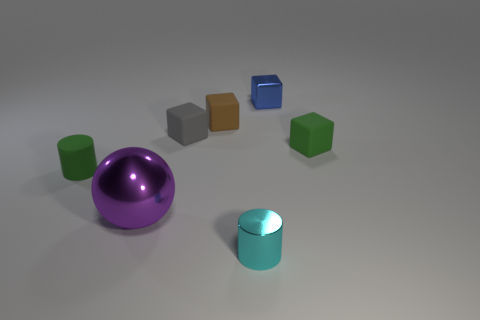There is a matte cube left of the tiny brown rubber thing on the right side of the matte cylinder; what color is it?
Give a very brief answer. Gray. How many small shiny objects are in front of the green rubber block and behind the small brown object?
Provide a short and direct response. 0. Are there more big red matte cylinders than tiny green matte blocks?
Make the answer very short. No. What material is the big purple thing?
Your answer should be very brief. Metal. There is a tiny green matte object left of the metallic sphere; how many tiny cylinders are on the left side of it?
Your response must be concise. 0. There is a big shiny thing; is its color the same as the metal thing that is behind the ball?
Make the answer very short. No. What is the color of the other shiny object that is the same size as the cyan metal thing?
Give a very brief answer. Blue. Is there a green metallic object of the same shape as the small gray matte thing?
Provide a succinct answer. No. Is the number of small brown rubber objects less than the number of cyan metal spheres?
Offer a very short reply. No. What color is the cylinder on the right side of the tiny gray object?
Provide a short and direct response. Cyan. 